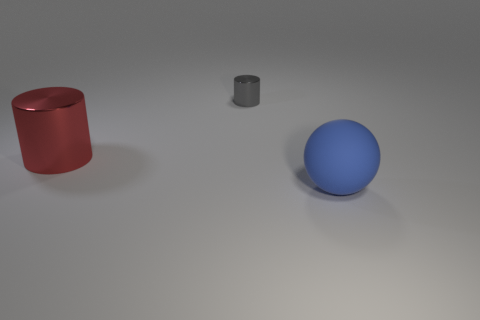Do the big red cylinder and the gray cylinder have the same material?
Offer a very short reply. Yes. Is the number of big matte things less than the number of green rubber things?
Offer a very short reply. No. Does the red metallic object have the same shape as the tiny metal object?
Ensure brevity in your answer.  Yes. The big cylinder has what color?
Keep it short and to the point. Red. How many other objects are there of the same material as the red cylinder?
Your response must be concise. 1. What number of gray objects are either large rubber objects or tiny metal things?
Keep it short and to the point. 1. There is a big object right of the big metal thing; is its shape the same as the large thing on the left side of the blue ball?
Make the answer very short. No. How many things are either blue rubber balls or large things in front of the red metal thing?
Offer a terse response. 1. What material is the object that is both right of the big red object and in front of the gray thing?
Offer a very short reply. Rubber. What is the cylinder on the right side of the large shiny cylinder made of?
Your response must be concise. Metal. 